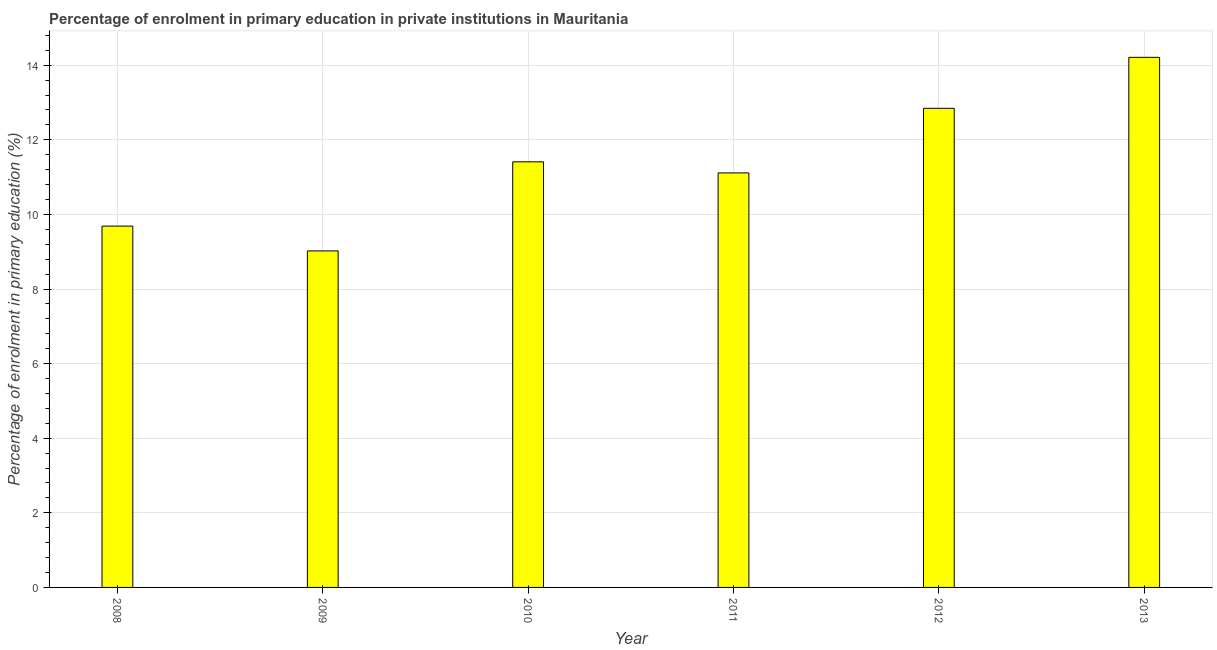Does the graph contain grids?
Ensure brevity in your answer.  Yes. What is the title of the graph?
Your answer should be compact. Percentage of enrolment in primary education in private institutions in Mauritania. What is the label or title of the X-axis?
Offer a very short reply. Year. What is the label or title of the Y-axis?
Your response must be concise. Percentage of enrolment in primary education (%). What is the enrolment percentage in primary education in 2009?
Keep it short and to the point. 9.02. Across all years, what is the maximum enrolment percentage in primary education?
Make the answer very short. 14.21. Across all years, what is the minimum enrolment percentage in primary education?
Provide a short and direct response. 9.02. In which year was the enrolment percentage in primary education maximum?
Offer a very short reply. 2013. What is the sum of the enrolment percentage in primary education?
Your answer should be compact. 68.29. What is the difference between the enrolment percentage in primary education in 2008 and 2009?
Ensure brevity in your answer.  0.67. What is the average enrolment percentage in primary education per year?
Your response must be concise. 11.38. What is the median enrolment percentage in primary education?
Make the answer very short. 11.26. In how many years, is the enrolment percentage in primary education greater than 2 %?
Make the answer very short. 6. Do a majority of the years between 2008 and 2013 (inclusive) have enrolment percentage in primary education greater than 2.4 %?
Make the answer very short. Yes. What is the ratio of the enrolment percentage in primary education in 2011 to that in 2013?
Your answer should be compact. 0.78. Is the enrolment percentage in primary education in 2011 less than that in 2013?
Keep it short and to the point. Yes. Is the difference between the enrolment percentage in primary education in 2008 and 2013 greater than the difference between any two years?
Give a very brief answer. No. What is the difference between the highest and the second highest enrolment percentage in primary education?
Your answer should be compact. 1.37. Is the sum of the enrolment percentage in primary education in 2008 and 2010 greater than the maximum enrolment percentage in primary education across all years?
Your answer should be compact. Yes. What is the difference between the highest and the lowest enrolment percentage in primary education?
Provide a short and direct response. 5.19. Are all the bars in the graph horizontal?
Ensure brevity in your answer.  No. How many years are there in the graph?
Your answer should be compact. 6. What is the difference between two consecutive major ticks on the Y-axis?
Your response must be concise. 2. Are the values on the major ticks of Y-axis written in scientific E-notation?
Provide a short and direct response. No. What is the Percentage of enrolment in primary education (%) of 2008?
Make the answer very short. 9.69. What is the Percentage of enrolment in primary education (%) of 2009?
Make the answer very short. 9.02. What is the Percentage of enrolment in primary education (%) of 2010?
Provide a succinct answer. 11.41. What is the Percentage of enrolment in primary education (%) in 2011?
Ensure brevity in your answer.  11.11. What is the Percentage of enrolment in primary education (%) of 2012?
Ensure brevity in your answer.  12.84. What is the Percentage of enrolment in primary education (%) in 2013?
Give a very brief answer. 14.21. What is the difference between the Percentage of enrolment in primary education (%) in 2008 and 2009?
Your answer should be very brief. 0.66. What is the difference between the Percentage of enrolment in primary education (%) in 2008 and 2010?
Your answer should be compact. -1.72. What is the difference between the Percentage of enrolment in primary education (%) in 2008 and 2011?
Give a very brief answer. -1.43. What is the difference between the Percentage of enrolment in primary education (%) in 2008 and 2012?
Your response must be concise. -3.16. What is the difference between the Percentage of enrolment in primary education (%) in 2008 and 2013?
Provide a short and direct response. -4.52. What is the difference between the Percentage of enrolment in primary education (%) in 2009 and 2010?
Your answer should be very brief. -2.39. What is the difference between the Percentage of enrolment in primary education (%) in 2009 and 2011?
Your response must be concise. -2.09. What is the difference between the Percentage of enrolment in primary education (%) in 2009 and 2012?
Offer a very short reply. -3.82. What is the difference between the Percentage of enrolment in primary education (%) in 2009 and 2013?
Your answer should be very brief. -5.19. What is the difference between the Percentage of enrolment in primary education (%) in 2010 and 2011?
Your answer should be compact. 0.3. What is the difference between the Percentage of enrolment in primary education (%) in 2010 and 2012?
Provide a short and direct response. -1.43. What is the difference between the Percentage of enrolment in primary education (%) in 2010 and 2013?
Your answer should be compact. -2.8. What is the difference between the Percentage of enrolment in primary education (%) in 2011 and 2012?
Your answer should be very brief. -1.73. What is the difference between the Percentage of enrolment in primary education (%) in 2011 and 2013?
Offer a very short reply. -3.1. What is the difference between the Percentage of enrolment in primary education (%) in 2012 and 2013?
Make the answer very short. -1.37. What is the ratio of the Percentage of enrolment in primary education (%) in 2008 to that in 2009?
Provide a succinct answer. 1.07. What is the ratio of the Percentage of enrolment in primary education (%) in 2008 to that in 2010?
Offer a terse response. 0.85. What is the ratio of the Percentage of enrolment in primary education (%) in 2008 to that in 2011?
Give a very brief answer. 0.87. What is the ratio of the Percentage of enrolment in primary education (%) in 2008 to that in 2012?
Give a very brief answer. 0.75. What is the ratio of the Percentage of enrolment in primary education (%) in 2008 to that in 2013?
Make the answer very short. 0.68. What is the ratio of the Percentage of enrolment in primary education (%) in 2009 to that in 2010?
Your response must be concise. 0.79. What is the ratio of the Percentage of enrolment in primary education (%) in 2009 to that in 2011?
Offer a very short reply. 0.81. What is the ratio of the Percentage of enrolment in primary education (%) in 2009 to that in 2012?
Give a very brief answer. 0.7. What is the ratio of the Percentage of enrolment in primary education (%) in 2009 to that in 2013?
Your answer should be compact. 0.64. What is the ratio of the Percentage of enrolment in primary education (%) in 2010 to that in 2011?
Offer a very short reply. 1.03. What is the ratio of the Percentage of enrolment in primary education (%) in 2010 to that in 2012?
Offer a very short reply. 0.89. What is the ratio of the Percentage of enrolment in primary education (%) in 2010 to that in 2013?
Provide a short and direct response. 0.8. What is the ratio of the Percentage of enrolment in primary education (%) in 2011 to that in 2012?
Provide a succinct answer. 0.86. What is the ratio of the Percentage of enrolment in primary education (%) in 2011 to that in 2013?
Your answer should be compact. 0.78. What is the ratio of the Percentage of enrolment in primary education (%) in 2012 to that in 2013?
Make the answer very short. 0.9. 